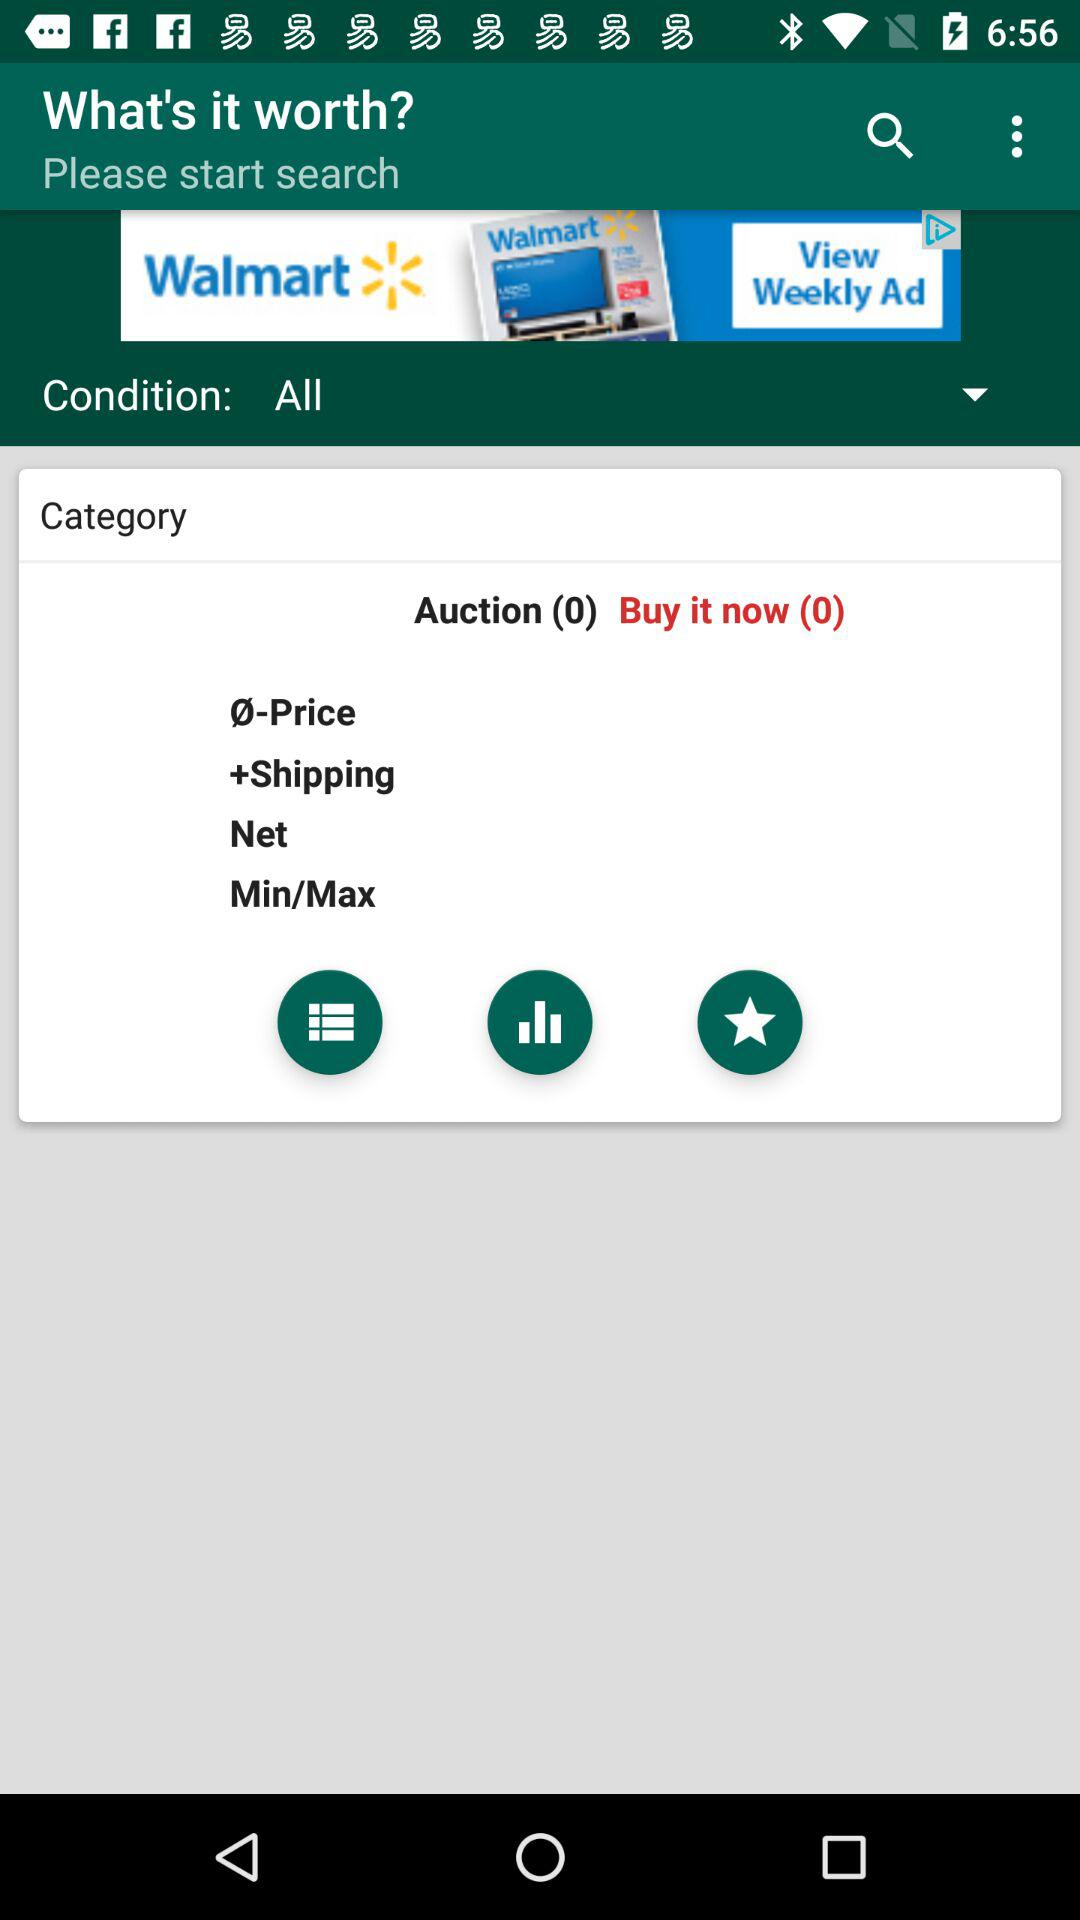What is the selected condition? The selected condition is "All". 